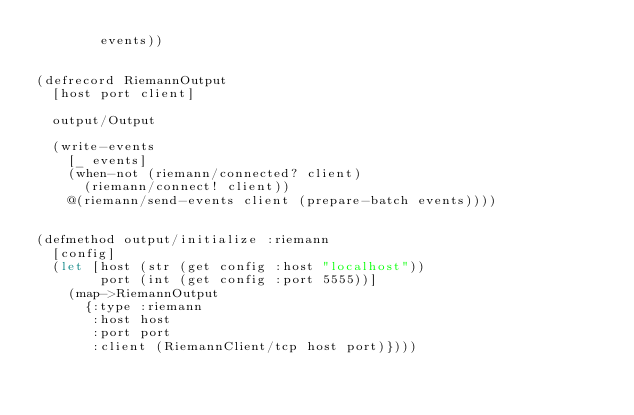Convert code to text. <code><loc_0><loc_0><loc_500><loc_500><_Clojure_>        events))


(defrecord RiemannOutput
  [host port client]

  output/Output

  (write-events
    [_ events]
    (when-not (riemann/connected? client)
      (riemann/connect! client))
    @(riemann/send-events client (prepare-batch events))))


(defmethod output/initialize :riemann
  [config]
  (let [host (str (get config :host "localhost"))
        port (int (get config :port 5555))]
    (map->RiemannOutput
      {:type :riemann
       :host host
       :port port
       :client (RiemannClient/tcp host port)})))
</code> 